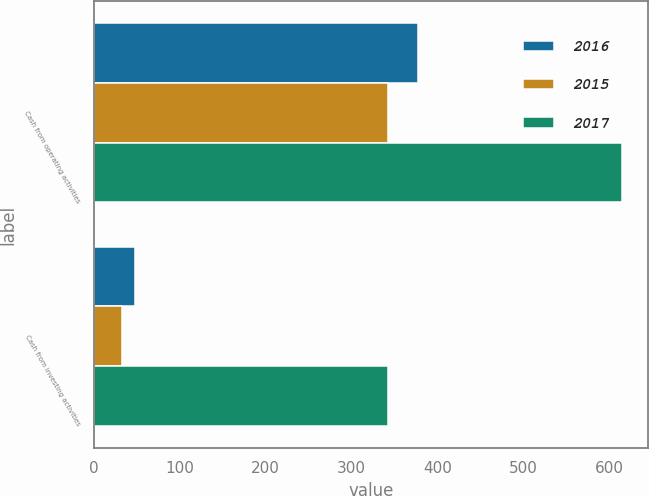<chart> <loc_0><loc_0><loc_500><loc_500><stacked_bar_chart><ecel><fcel>Cash from operating activities<fcel>Cash from investing activities<nl><fcel>2016<fcel>378<fcel>48<nl><fcel>2015<fcel>343<fcel>33<nl><fcel>2017<fcel>615<fcel>343<nl></chart> 